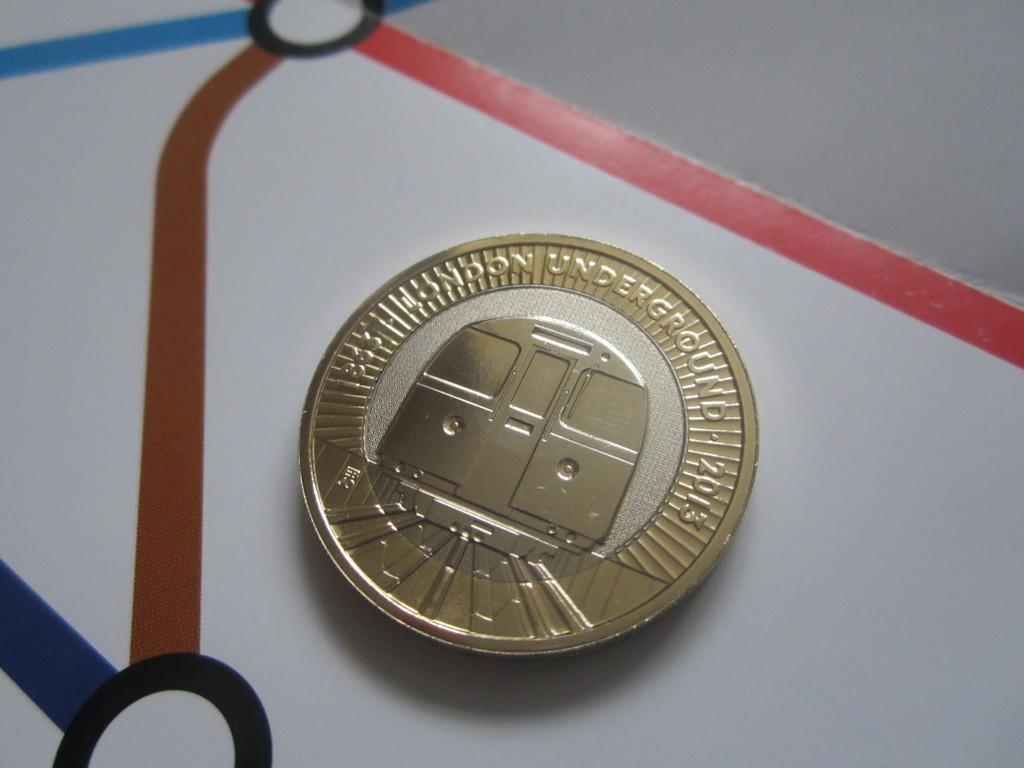What is the main subject of the image? The main subject of the image is a golden color coin. What is written on the coin? The coin has "London underground" and "2013" written on it. How many fans are visible in the image? There are no fans present in the image; it features a golden color coin with "London underground" and "2013" written on it. 